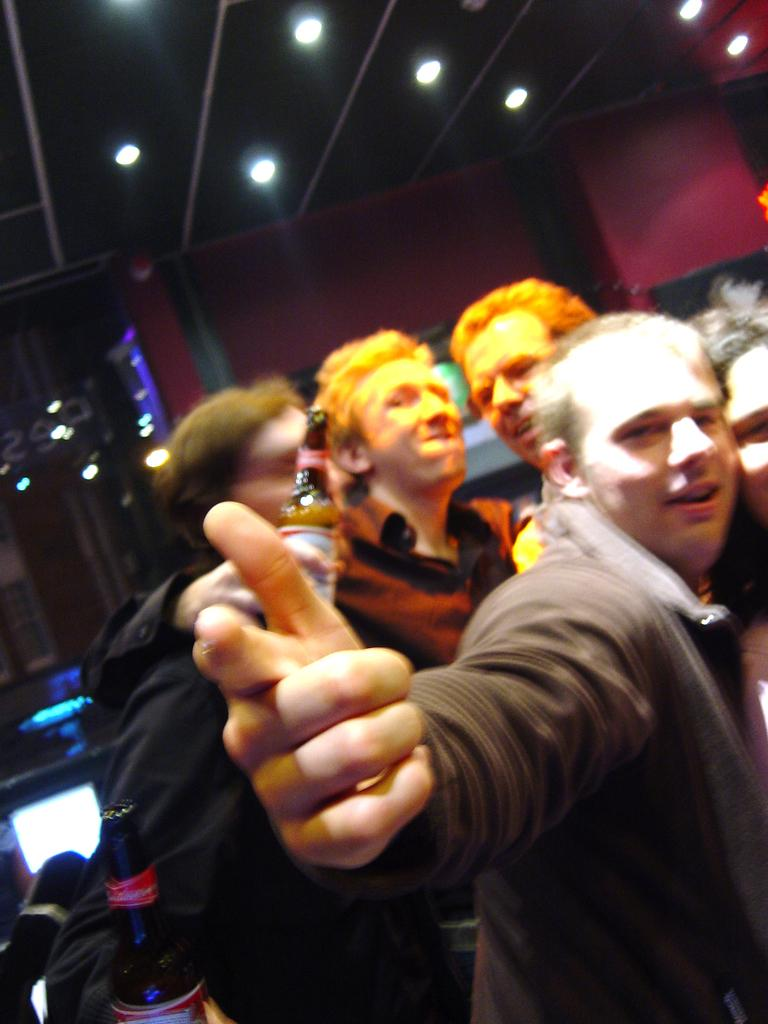How many people are in the image? There are people in the image, but the exact number is not specified. What are some of the people holding in the image? Some of the people are holding bottles in the image. Where are the people located in the image? The people are on the roof in the image. What can be seen on the roof besides the people? There are lights and poles on the roof in the image. What is visible in the background of the image? There is a wall visible in the background of the image. What type of decision is being made by the turkey in the image? There is no turkey present in the image, so no decision can be attributed to a turkey. 